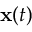Convert formula to latex. <formula><loc_0><loc_0><loc_500><loc_500>{ x } ( t )</formula> 